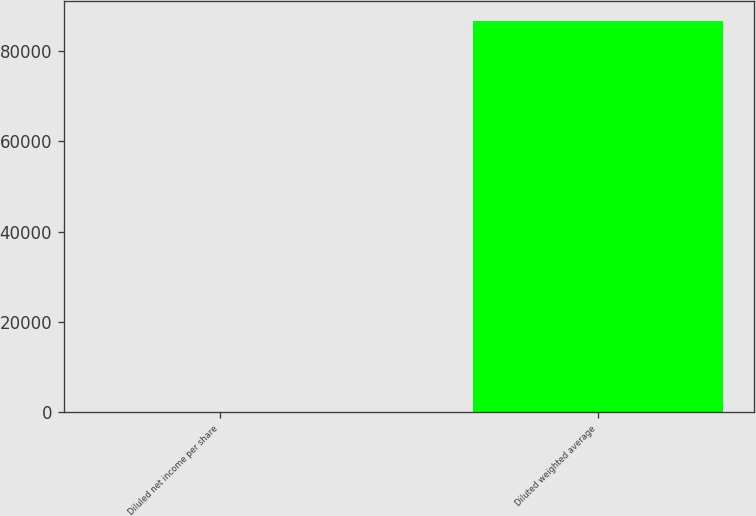Convert chart. <chart><loc_0><loc_0><loc_500><loc_500><bar_chart><fcel>Diluled net income per share<fcel>Diluted weighted average<nl><fcel>1.59<fcel>86687<nl></chart> 